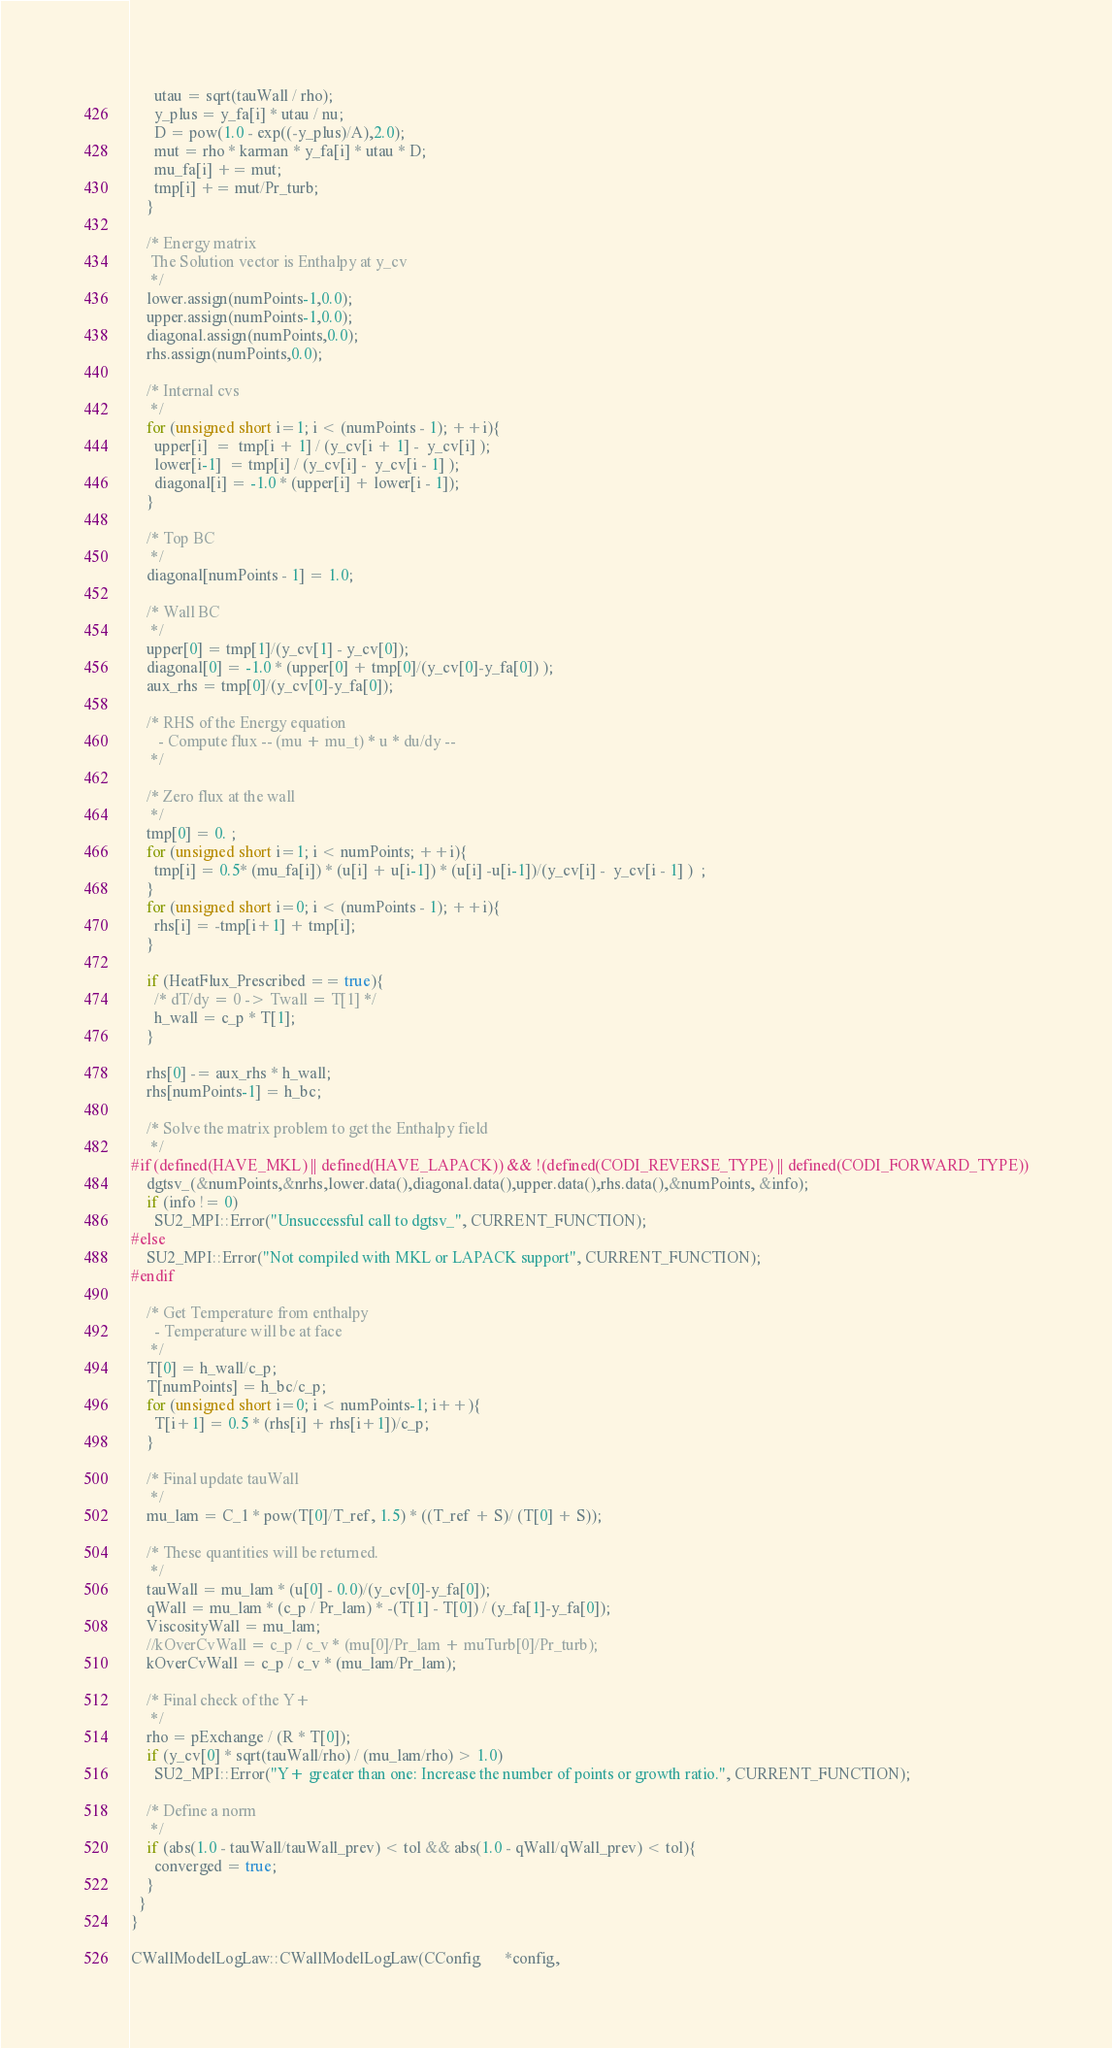<code> <loc_0><loc_0><loc_500><loc_500><_C++_>      utau = sqrt(tauWall / rho);
      y_plus = y_fa[i] * utau / nu;
      D = pow(1.0 - exp((-y_plus)/A),2.0);
      mut = rho * karman * y_fa[i] * utau * D;
      mu_fa[i] += mut;
      tmp[i] += mut/Pr_turb;
    }
    
    /* Energy matrix
     The Solution vector is Enthalpy at y_cv
     */
    lower.assign(numPoints-1,0.0);
    upper.assign(numPoints-1,0.0);
    diagonal.assign(numPoints,0.0);
    rhs.assign(numPoints,0.0);
    
    /* Internal cvs
     */
    for (unsigned short i=1; i < (numPoints - 1); ++i){
      upper[i]  =  tmp[i + 1] / (y_cv[i + 1] -  y_cv[i] );
      lower[i-1]  = tmp[i] / (y_cv[i] -  y_cv[i - 1] );
      diagonal[i] = -1.0 * (upper[i] + lower[i - 1]);
    }
    
    /* Top BC
     */
    diagonal[numPoints - 1] = 1.0;
    
    /* Wall BC
     */
    upper[0] = tmp[1]/(y_cv[1] - y_cv[0]);
    diagonal[0] = -1.0 * (upper[0] + tmp[0]/(y_cv[0]-y_fa[0]) );
    aux_rhs = tmp[0]/(y_cv[0]-y_fa[0]);
    
    /* RHS of the Energy equation
       - Compute flux -- (mu + mu_t) * u * du/dy --
     */
    
    /* Zero flux at the wall
     */
    tmp[0] = 0. ;
    for (unsigned short i=1; i < numPoints; ++i){
      tmp[i] = 0.5* (mu_fa[i]) * (u[i] + u[i-1]) * (u[i] -u[i-1])/(y_cv[i] -  y_cv[i - 1] )  ;
    }
    for (unsigned short i=0; i < (numPoints - 1); ++i){
      rhs[i] = -tmp[i+1] + tmp[i];
    }
    
    if (HeatFlux_Prescribed == true){
      /* dT/dy = 0 -> Twall = T[1] */
      h_wall = c_p * T[1];
    }
    
    rhs[0] -= aux_rhs * h_wall;
    rhs[numPoints-1] = h_bc;
    
    /* Solve the matrix problem to get the Enthalpy field
     */
#if (defined(HAVE_MKL) || defined(HAVE_LAPACK)) && !(defined(CODI_REVERSE_TYPE) || defined(CODI_FORWARD_TYPE))
    dgtsv_(&numPoints,&nrhs,lower.data(),diagonal.data(),upper.data(),rhs.data(),&numPoints, &info);
    if (info != 0)
      SU2_MPI::Error("Unsuccessful call to dgtsv_", CURRENT_FUNCTION);
#else
    SU2_MPI::Error("Not compiled with MKL or LAPACK support", CURRENT_FUNCTION);
#endif

    /* Get Temperature from enthalpy
      - Temperature will be at face
     */
    T[0] = h_wall/c_p;
    T[numPoints] = h_bc/c_p;
    for (unsigned short i=0; i < numPoints-1; i++){
      T[i+1] = 0.5 * (rhs[i] + rhs[i+1])/c_p;
    }
    
    /* Final update tauWall
     */
    mu_lam = C_1 * pow(T[0]/T_ref, 1.5) * ((T_ref + S)/ (T[0] + S));
    
    /* These quantities will be returned.
     */
    tauWall = mu_lam * (u[0] - 0.0)/(y_cv[0]-y_fa[0]);
    qWall = mu_lam * (c_p / Pr_lam) * -(T[1] - T[0]) / (y_fa[1]-y_fa[0]);
    ViscosityWall = mu_lam;
    //kOverCvWall = c_p / c_v * (mu[0]/Pr_lam + muTurb[0]/Pr_turb);
    kOverCvWall = c_p / c_v * (mu_lam/Pr_lam);
    
    /* Final check of the Y+
     */
    rho = pExchange / (R * T[0]);
    if (y_cv[0] * sqrt(tauWall/rho) / (mu_lam/rho) > 1.0)
      SU2_MPI::Error("Y+ greater than one: Increase the number of points or growth ratio.", CURRENT_FUNCTION);
    
    /* Define a norm
     */
    if (abs(1.0 - tauWall/tauWall_prev) < tol && abs(1.0 - qWall/qWall_prev) < tol){
      converged = true;
    }
  }
}

CWallModelLogLaw::CWallModelLogLaw(CConfig      *config,</code> 